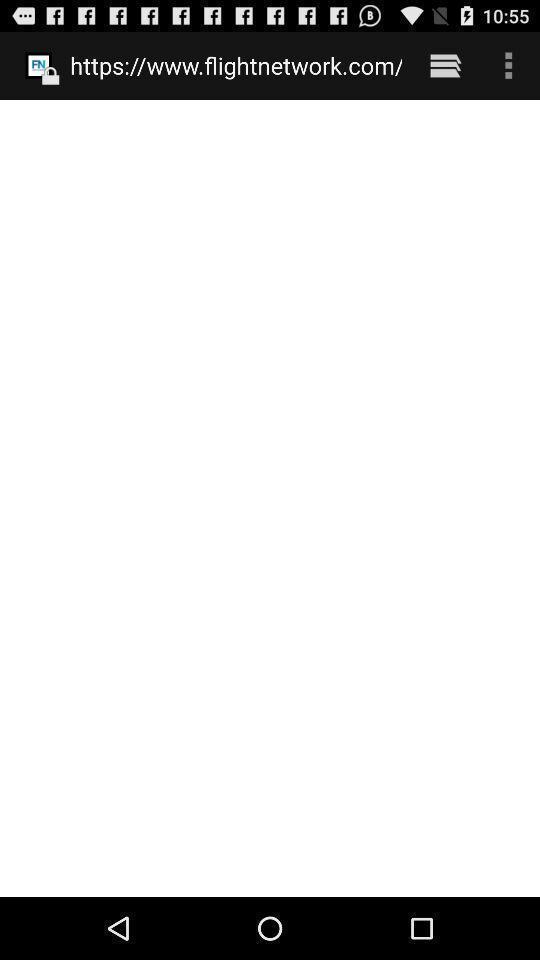Provide a description of this screenshot. Search window browsing about flights. 